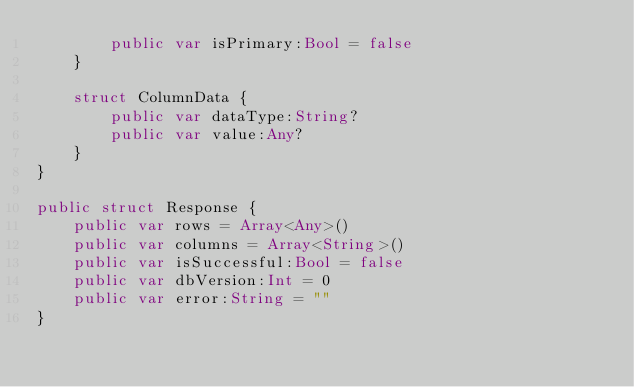<code> <loc_0><loc_0><loc_500><loc_500><_Swift_>        public var isPrimary:Bool = false
    }
    
    struct ColumnData {
        public var dataType:String?
        public var value:Any?
    }
}

public struct Response {
    public var rows = Array<Any>()
    public var columns = Array<String>()
    public var isSuccessful:Bool = false
    public var dbVersion:Int = 0
    public var error:String = ""
}
</code> 